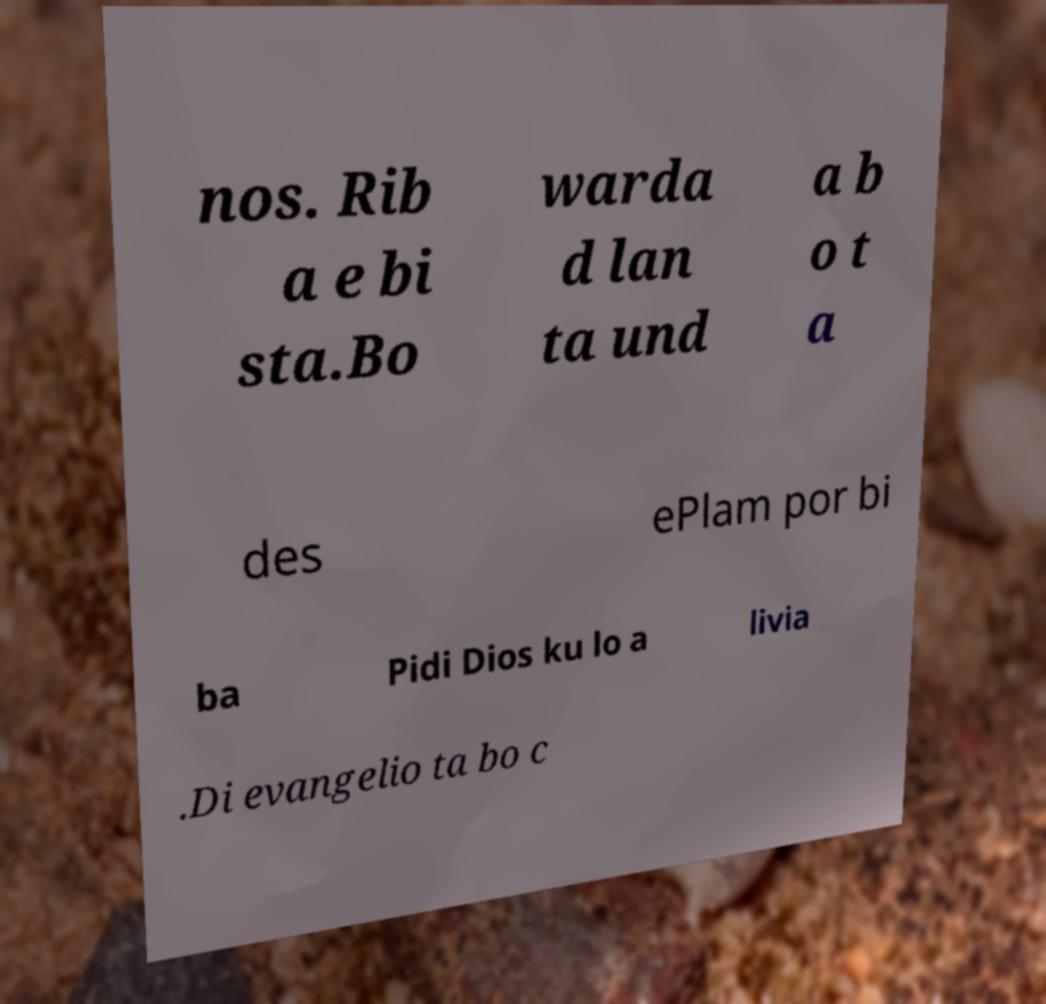What messages or text are displayed in this image? I need them in a readable, typed format. nos. Rib a e bi sta.Bo warda d lan ta und a b o t a des ePlam por bi ba Pidi Dios ku lo a livia .Di evangelio ta bo c 